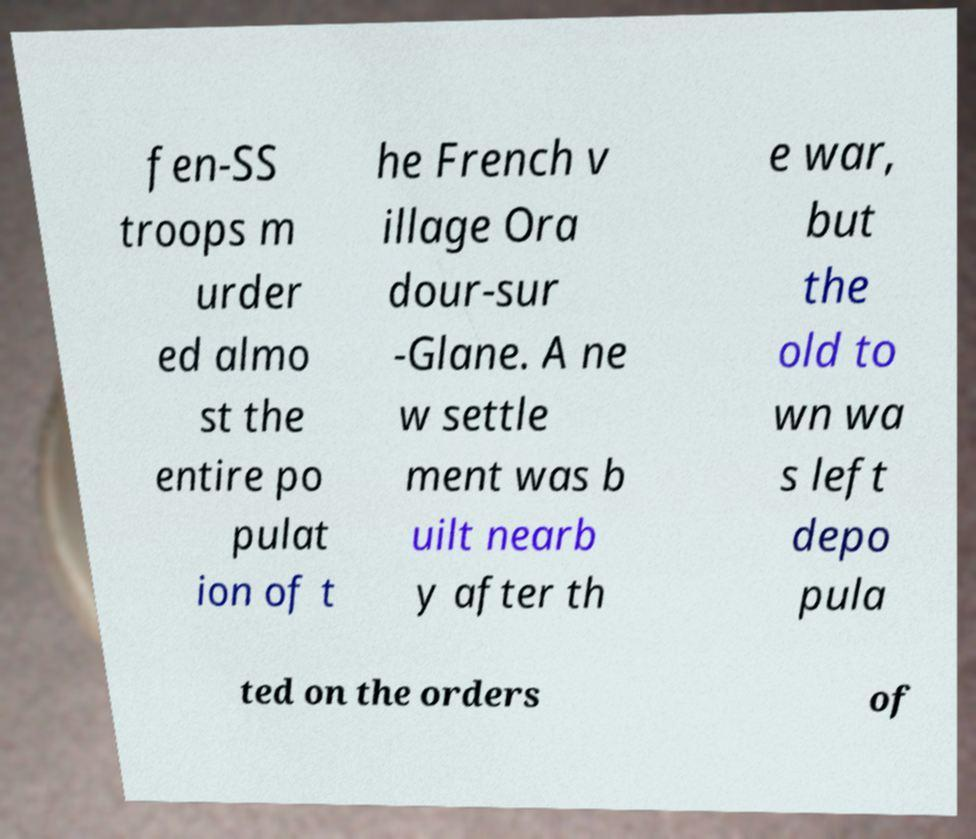I need the written content from this picture converted into text. Can you do that? fen-SS troops m urder ed almo st the entire po pulat ion of t he French v illage Ora dour-sur -Glane. A ne w settle ment was b uilt nearb y after th e war, but the old to wn wa s left depo pula ted on the orders of 